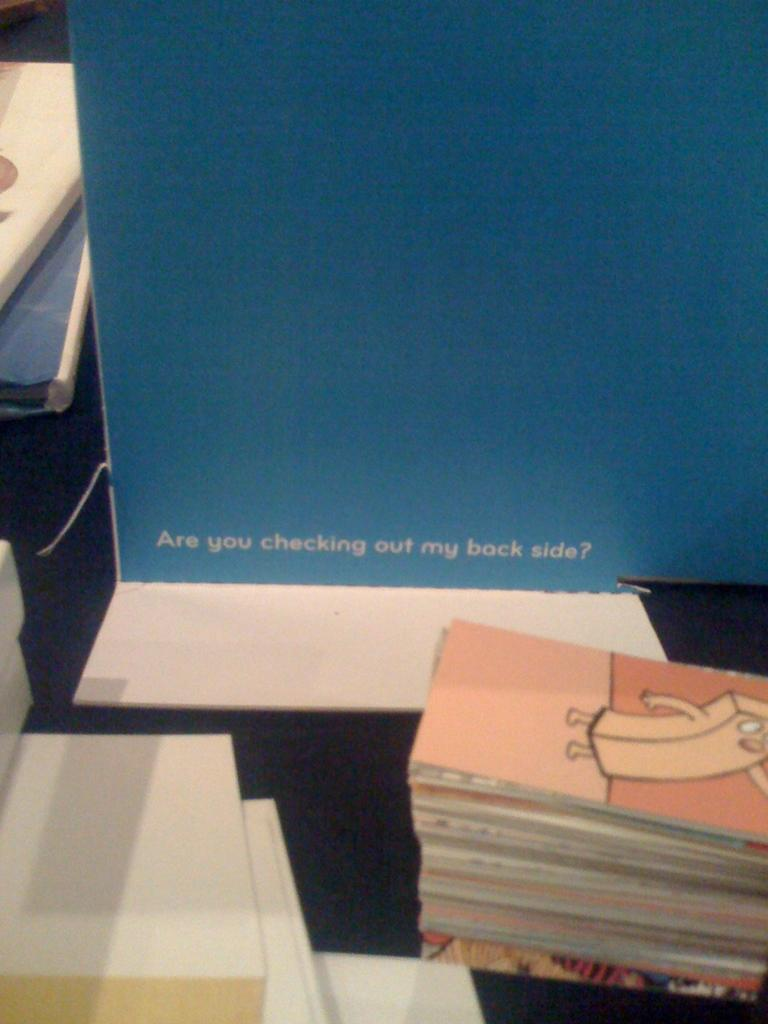<image>
Summarize the visual content of the image. A placard that says "Are you checking out my back side?" is sitting on a table. 